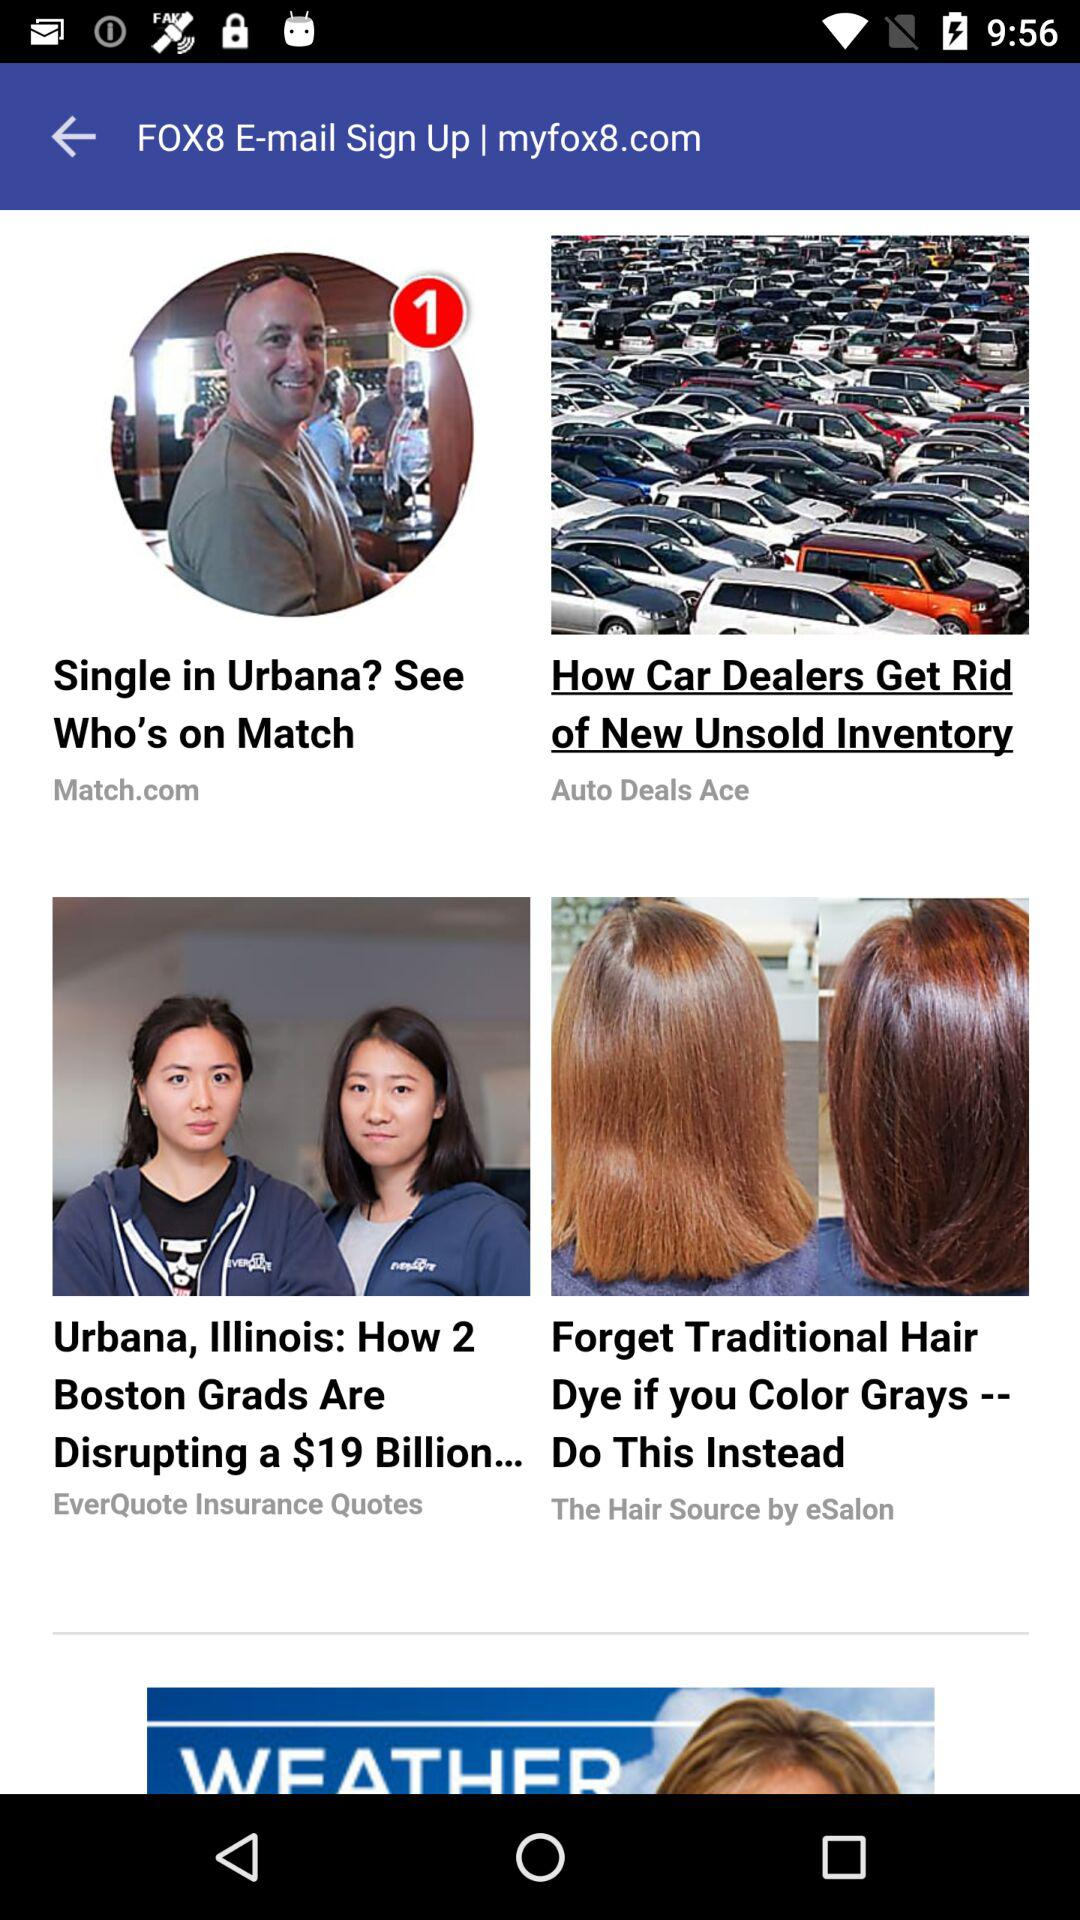Which email address was used to sign up?
When the provided information is insufficient, respond with <no answer>. <no answer> 